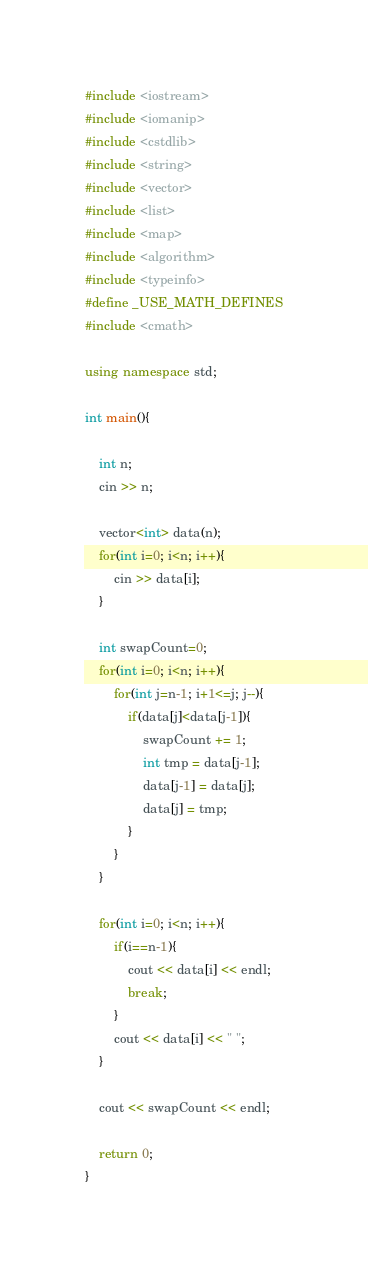Convert code to text. <code><loc_0><loc_0><loc_500><loc_500><_C++_>#include <iostream>
#include <iomanip>
#include <cstdlib>
#include <string>
#include <vector>
#include <list>
#include <map>
#include <algorithm>
#include <typeinfo>
#define _USE_MATH_DEFINES
#include <cmath>

using namespace std;

int main(){

    int n;
    cin >> n;

    vector<int> data(n);
    for(int i=0; i<n; i++){
        cin >> data[i];
    }

    int swapCount=0;
    for(int i=0; i<n; i++){
        for(int j=n-1; i+1<=j; j--){
            if(data[j]<data[j-1]){
                swapCount += 1;
                int tmp = data[j-1];
                data[j-1] = data[j];
                data[j] = tmp;
            }
        }
    }

    for(int i=0; i<n; i++){
        if(i==n-1){
            cout << data[i] << endl;
            break;
        }
        cout << data[i] << " ";
    }

    cout << swapCount << endl;

    return 0;
}

</code> 